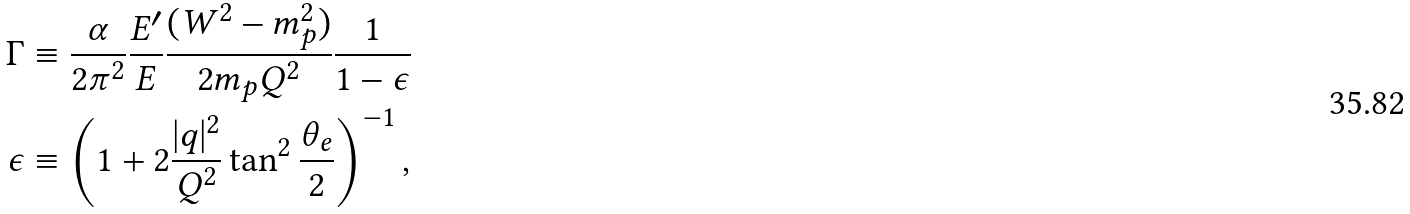Convert formula to latex. <formula><loc_0><loc_0><loc_500><loc_500>\Gamma & \equiv \frac { \alpha } { 2 \pi ^ { 2 } } \frac { E ^ { \prime } } { E } \frac { ( W ^ { 2 } - m _ { p } ^ { 2 } ) } { 2 m _ { p } Q ^ { 2 } } \frac { 1 } { 1 - \epsilon } \\ \epsilon & \equiv \left ( 1 + 2 \frac { | q | ^ { 2 } } { Q ^ { 2 } } \tan ^ { 2 } { \frac { \theta _ { e } } { 2 } } \right ) ^ { - 1 } , \\</formula> 